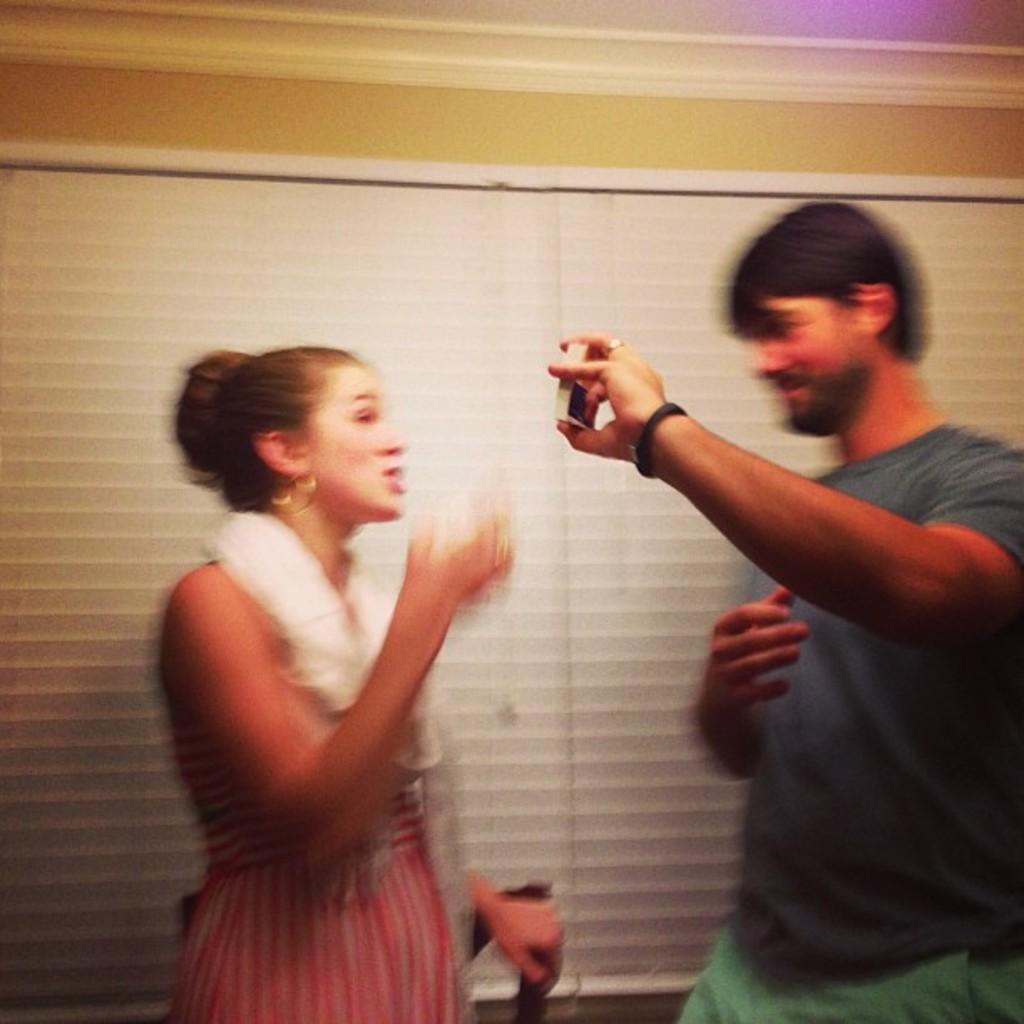Please provide a concise description of this image. In this image we can see a man holding an object. We can also see the woman standing. In the background we can see the wall, window mat and also the ceiling at the top. 